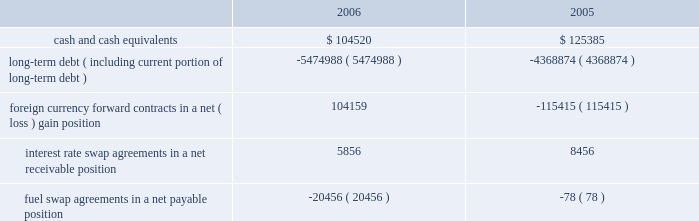Note 9 .
Retirement plan we maintain a defined contribution pension plan covering full-time shoreside employees who have completed the minimum period of continuous service .
Annual contributions to the plan are based on fixed percentages of participants 2019 salaries and years of service , not to exceed certain maximums .
Pension cost was $ 13.9 million , $ 12.8 million and $ 12.2 million for the years ended december 31 , 2006 , 2005 and 2004 , respectively .
Note 10 .
Income taxes we and the majority of our subsidiaries are currently exempt from united states corporate tax on income from the international opera- tion of ships pursuant to section 883 of the internal revenue code .
Income tax expense related to our remaining subsidiaries was not significant for the years ended december 31 , 2006 , 2005 and 2004 .
Final regulations under section 883 were published on august 26 , 2003 , and were effective for the year ended december 31 , 2005 .
These regulations confirmed that we qualify for the exemption provid- ed by section 883 , but also narrowed the scope of activities which are considered by the internal revenue service to be incidental to the international operation of ships .
The activities listed in the regula- tions as not being incidental to the international operation of ships include income from the sale of air and other transportation such as transfers , shore excursions and pre and post cruise tours .
To the extent the income from such activities is earned from sources within the united states , such income will be subject to united states taxa- tion .
The application of these new regulations reduced our net income for the years ended december 31 , 2006 and december 31 , 2005 by approximately $ 6.3 million and $ 14.0 million , respectively .
Note 11 .
Financial instruments the estimated fair values of our financial instruments are as follows ( in thousands ) : .
Long-term debt ( including current portion of long-term debt ) ( 5474988 ) ( 4368874 ) foreign currency forward contracts in a net ( loss ) gain position 104159 ( 115415 ) interest rate swap agreements in a net receivable position 5856 8456 fuel swap agreements in a net payable position ( 20456 ) ( 78 ) the reported fair values are based on a variety of factors and assumptions .
Accordingly , the fair values may not represent actual values of the financial instruments that could have been realized as of december 31 , 2006 or 2005 , or that will be realized in the future and do not include expenses that could be incurred in an actual sale or settlement .
Our financial instruments are not held for trading or speculative purposes .
Our exposure under foreign currency contracts , interest rate and fuel swap agreements is limited to the cost of replacing the contracts in the event of non-performance by the counterparties to the contracts , all of which are currently our lending banks .
To minimize this risk , we select counterparties with credit risks acceptable to us and we limit our exposure to an individual counterparty .
Furthermore , all foreign currency forward contracts are denominated in primary currencies .
Cash and cash equivalents the carrying amounts of cash and cash equivalents approximate their fair values due to the short maturity of these instruments .
Long-term debt the fair values of our senior notes and senior debentures were esti- mated by obtaining quoted market prices .
The fair values of all other debt were estimated using discounted cash flow analyses based on market rates available to us for similar debt with the same remaining maturities .
Foreign currency contracts the fair values of our foreign currency forward contracts were esti- mated using current market prices for similar instruments .
Our expo- sure to market risk for fluctuations in foreign currency exchange rates relates to six ship construction contracts and forecasted transactions .
We use foreign currency forward contracts to mitigate the impact of fluctuations in foreign currency exchange rates .
As of december 31 , 2006 , we had foreign currency forward contracts in a notional amount of $ 3.8 billion maturing through 2009 .
As of december 31 , 2006 , the fair value of our foreign currency forward contracts related to the six ship construction contracts , which are designated as fair value hedges , was a net unrealized gain of approximately $ 106.3 mil- lion .
At december 31 , 2005 , the fair value of our foreign currency for- ward contracts related to three ship construction contracts , designated as fair value hedges , was a net unrealized loss of approx- imately $ 103.4 million .
The fair value of our foreign currency forward contracts related to the other ship construction contract at december 31 , 2005 , which was designated as a cash flow hedge , was an unre- alized loss , of approximately $ 7.8 million .
At december 31 , 2006 , approximately 11% ( 11 % ) of the aggregate cost of the ships was exposed to fluctuations in the euro exchange rate .
R o y a l c a r i b b e a n c r u i s e s l t d .
3 5 notes to the consolidated financial statements ( continued ) 51392_financials-v9.qxp 6/7/07 3:40 pm page 35 .
What is the ratio of total cash to total long-term debt? 
Rationale: turn 0.02 into ratio form
Computations: ((104520 + 125385) / (5474988 + 4368874))
Answer: 0.02336. 